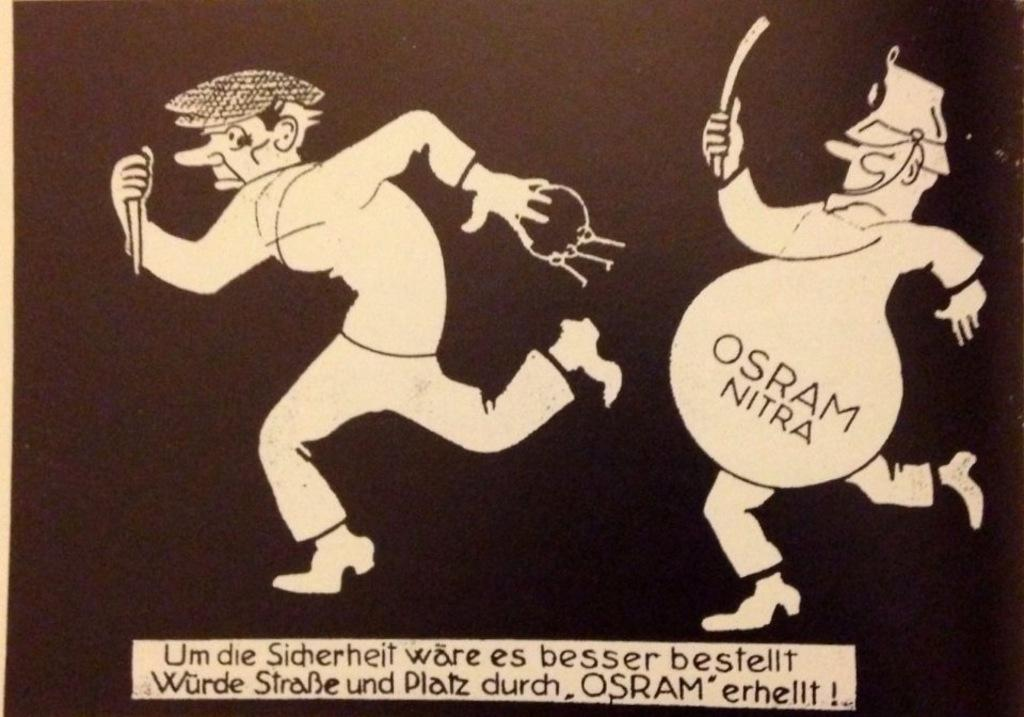What is featured in the image? There is a poster in the image. What can be seen on the poster? The poster contains two cartoon pictures. Is there any text on the poster? Yes, there is text at the bottom of the poster. What type of baseball coil can be seen in the image? There is no baseball or coil present in the image; it features a poster with two cartoon pictures and text at the bottom. 